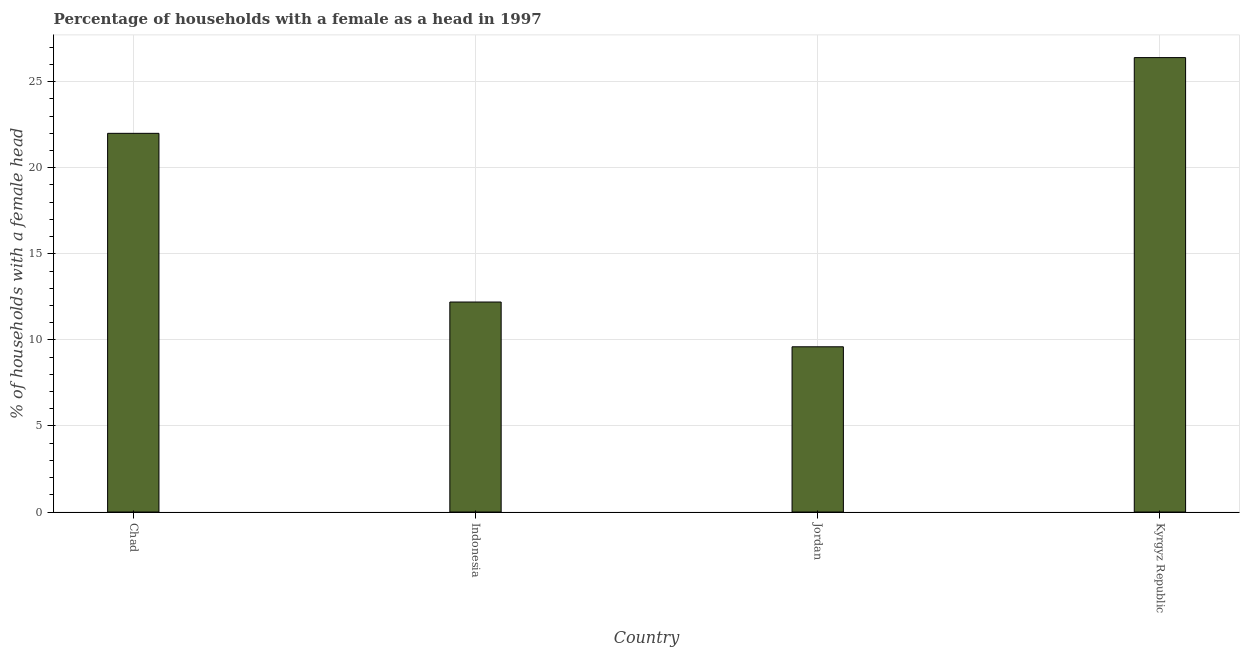Does the graph contain grids?
Provide a short and direct response. Yes. What is the title of the graph?
Keep it short and to the point. Percentage of households with a female as a head in 1997. What is the label or title of the X-axis?
Ensure brevity in your answer.  Country. What is the label or title of the Y-axis?
Offer a terse response. % of households with a female head. What is the number of female supervised households in Kyrgyz Republic?
Your answer should be very brief. 26.4. Across all countries, what is the maximum number of female supervised households?
Offer a very short reply. 26.4. In which country was the number of female supervised households maximum?
Offer a terse response. Kyrgyz Republic. In which country was the number of female supervised households minimum?
Keep it short and to the point. Jordan. What is the sum of the number of female supervised households?
Provide a succinct answer. 70.2. What is the average number of female supervised households per country?
Give a very brief answer. 17.55. What is the ratio of the number of female supervised households in Indonesia to that in Kyrgyz Republic?
Your answer should be compact. 0.46. Is the sum of the number of female supervised households in Indonesia and Jordan greater than the maximum number of female supervised households across all countries?
Offer a terse response. No. What is the difference between the highest and the lowest number of female supervised households?
Your response must be concise. 16.8. In how many countries, is the number of female supervised households greater than the average number of female supervised households taken over all countries?
Provide a short and direct response. 2. How many bars are there?
Offer a very short reply. 4. What is the % of households with a female head of Chad?
Provide a succinct answer. 22. What is the % of households with a female head in Jordan?
Ensure brevity in your answer.  9.6. What is the % of households with a female head of Kyrgyz Republic?
Your response must be concise. 26.4. What is the difference between the % of households with a female head in Chad and Jordan?
Your answer should be compact. 12.4. What is the difference between the % of households with a female head in Jordan and Kyrgyz Republic?
Offer a very short reply. -16.8. What is the ratio of the % of households with a female head in Chad to that in Indonesia?
Offer a terse response. 1.8. What is the ratio of the % of households with a female head in Chad to that in Jordan?
Ensure brevity in your answer.  2.29. What is the ratio of the % of households with a female head in Chad to that in Kyrgyz Republic?
Offer a terse response. 0.83. What is the ratio of the % of households with a female head in Indonesia to that in Jordan?
Keep it short and to the point. 1.27. What is the ratio of the % of households with a female head in Indonesia to that in Kyrgyz Republic?
Your answer should be compact. 0.46. What is the ratio of the % of households with a female head in Jordan to that in Kyrgyz Republic?
Give a very brief answer. 0.36. 